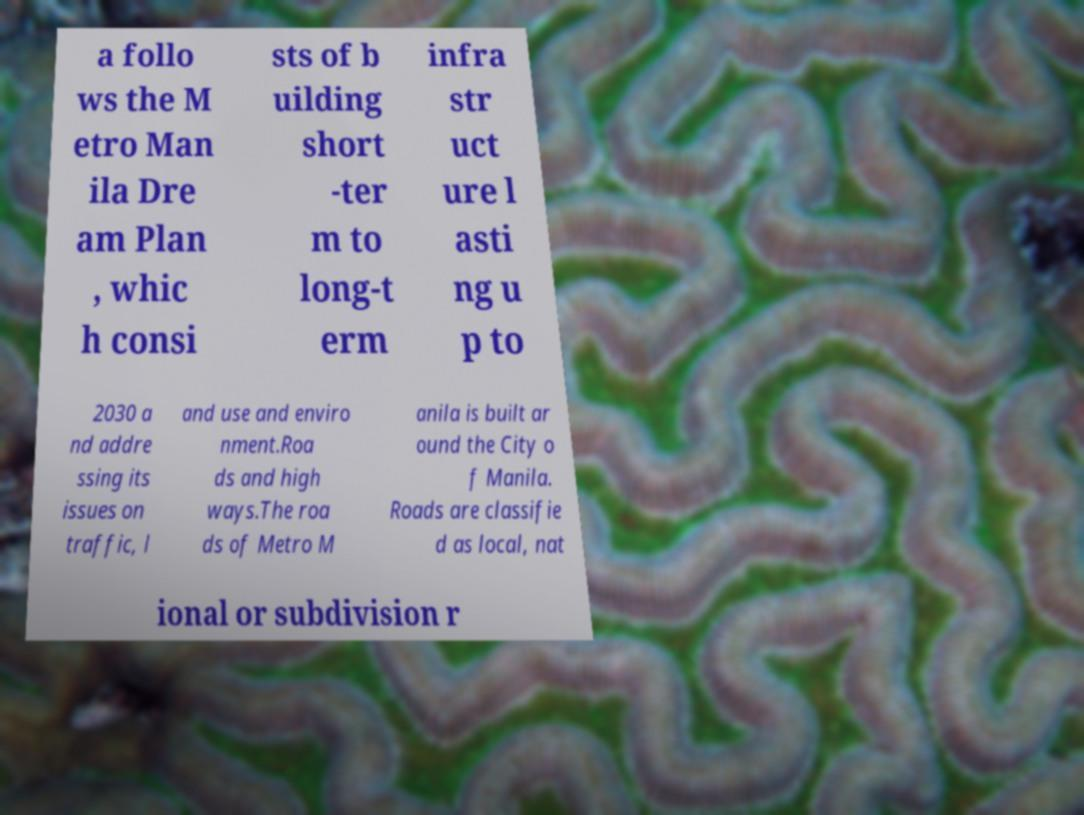For documentation purposes, I need the text within this image transcribed. Could you provide that? a follo ws the M etro Man ila Dre am Plan , whic h consi sts of b uilding short -ter m to long-t erm infra str uct ure l asti ng u p to 2030 a nd addre ssing its issues on traffic, l and use and enviro nment.Roa ds and high ways.The roa ds of Metro M anila is built ar ound the City o f Manila. Roads are classifie d as local, nat ional or subdivision r 